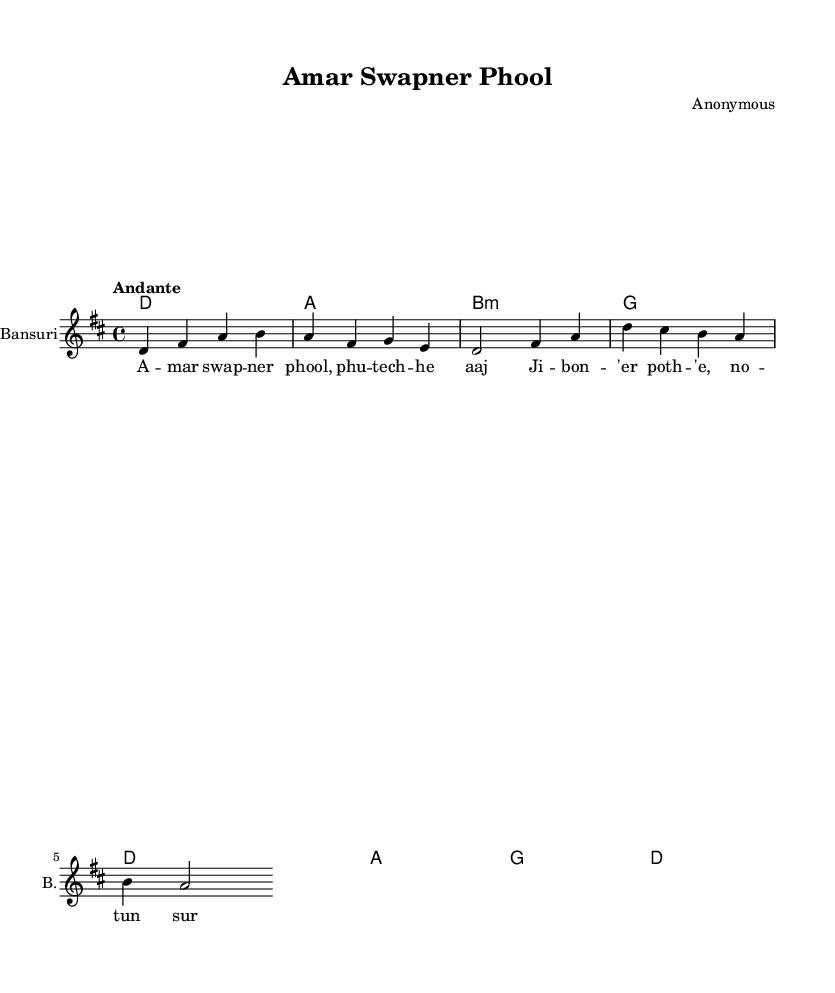What is the key signature of this music? The key signature is D major, which has two sharps: F sharp and C sharp. This is typically indicated at the beginning of the staff before the notes begin.
Answer: D major What is the time signature of this piece? The time signature is 4/4, meaning there are four beats in each measure and a quarter note gets one beat. This can be found at the start of the score.
Answer: 4/4 What is the tempo marking of the composition? The tempo marking shown is "Andante", which suggests the music should be played at a moderate pace, generally around 76-108 beats per minute. This is indicated above the staff.
Answer: Andante How many measures are in the melody line? The melody line consists of four measures, which can be counted naturally by looking at the groupings of notes separated by vertical bar lines on the staff.
Answer: Four What is the instrument indicated for the melody? The music specifies the Bansuri as the instrument for the melody, which is mentioned in the instrument name area at the beginning of the staff.
Answer: Bansuri What themes are celebrated in this Bengali love ballad? The lyrics describe personal growth and success through the metaphor of flowers and new beginnings on life's path, which reflects a common theme in romantic Bengali ballads. While not directly visible in the sheet music, this interpretation is derived from the essence of the lyrics provided.
Answer: Personal growth 